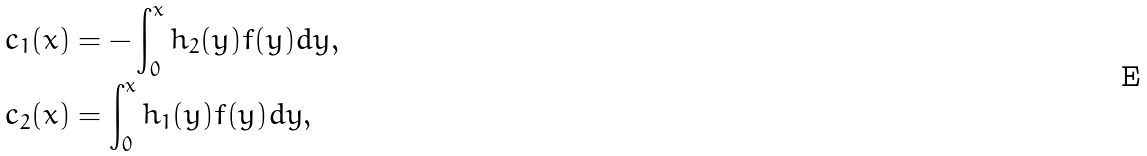Convert formula to latex. <formula><loc_0><loc_0><loc_500><loc_500>c _ { 1 } ( x ) & = - \int _ { 0 } ^ { x } h _ { 2 } ( y ) f ( y ) d y , \\ c _ { 2 } ( x ) & = \int _ { 0 } ^ { x } h _ { 1 } ( y ) f ( y ) d y ,</formula> 